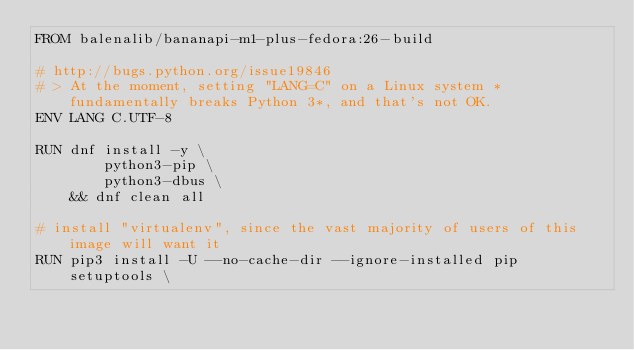Convert code to text. <code><loc_0><loc_0><loc_500><loc_500><_Dockerfile_>FROM balenalib/bananapi-m1-plus-fedora:26-build

# http://bugs.python.org/issue19846
# > At the moment, setting "LANG=C" on a Linux system *fundamentally breaks Python 3*, and that's not OK.
ENV LANG C.UTF-8

RUN dnf install -y \
		python3-pip \
		python3-dbus \
	&& dnf clean all

# install "virtualenv", since the vast majority of users of this image will want it
RUN pip3 install -U --no-cache-dir --ignore-installed pip setuptools \</code> 